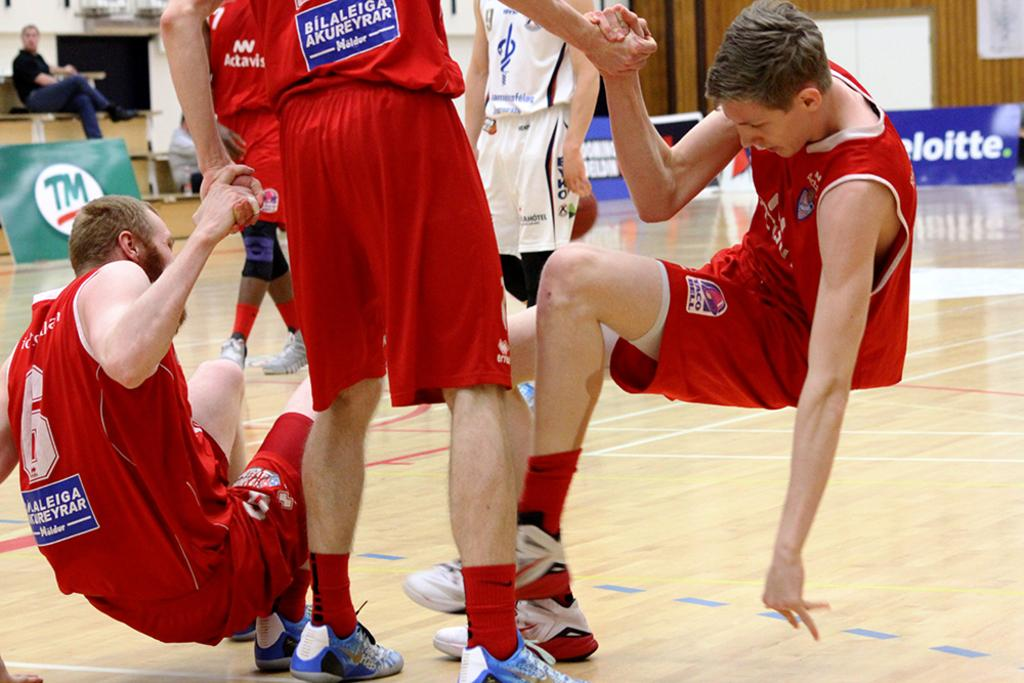<image>
Present a compact description of the photo's key features. Three Bilalaleiga Akureyrar basket ball players holding hands on the court 